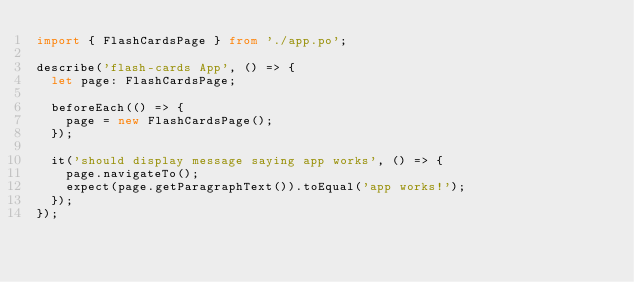Convert code to text. <code><loc_0><loc_0><loc_500><loc_500><_TypeScript_>import { FlashCardsPage } from './app.po';

describe('flash-cards App', () => {
  let page: FlashCardsPage;

  beforeEach(() => {
    page = new FlashCardsPage();
  });

  it('should display message saying app works', () => {
    page.navigateTo();
    expect(page.getParagraphText()).toEqual('app works!');
  });
});
</code> 